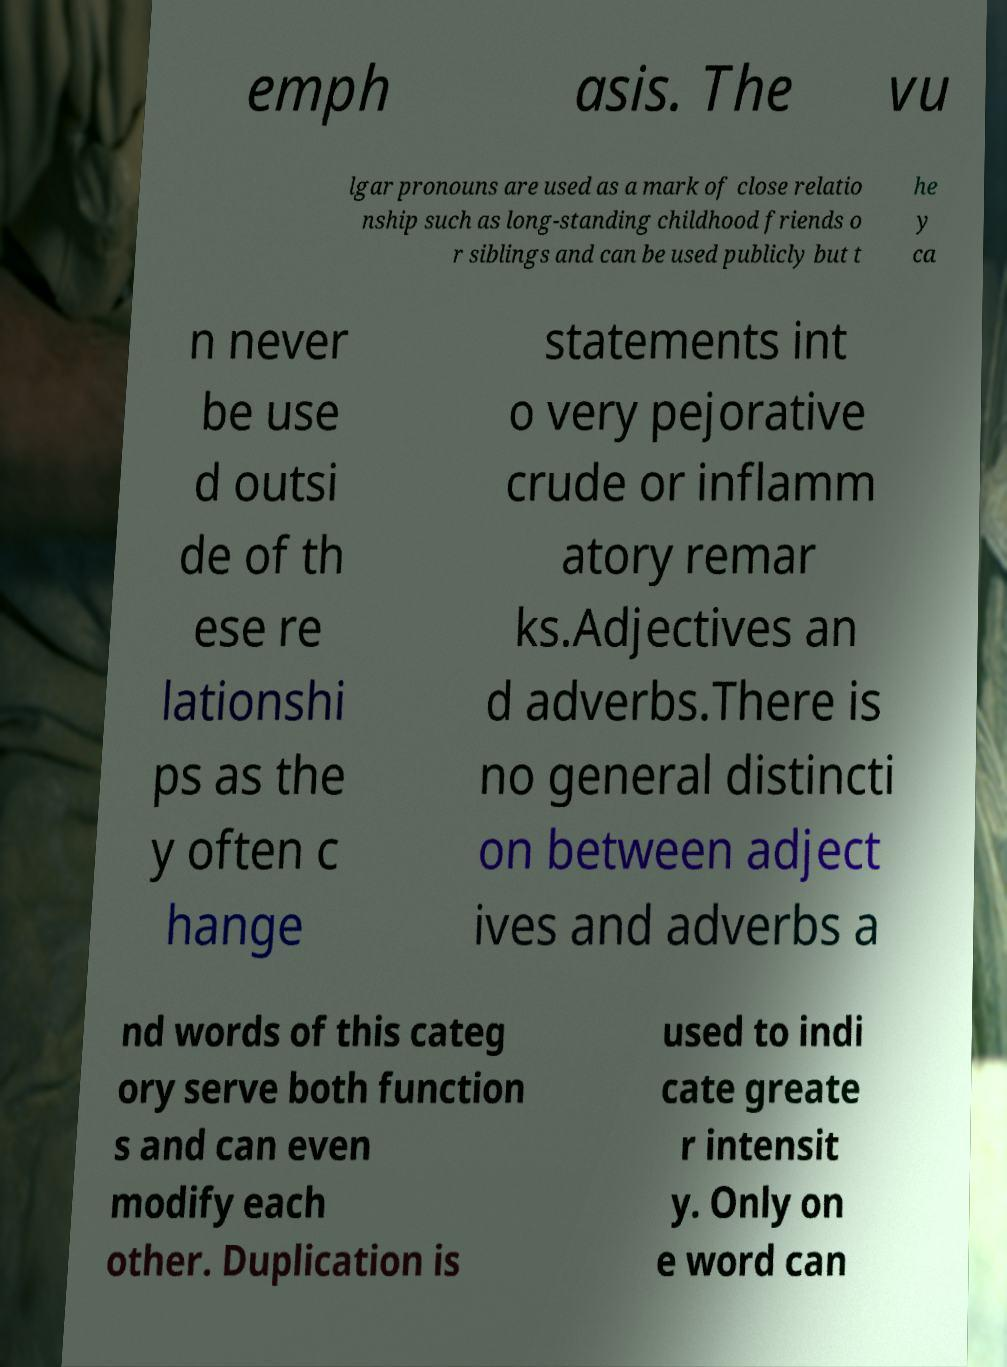For documentation purposes, I need the text within this image transcribed. Could you provide that? emph asis. The vu lgar pronouns are used as a mark of close relatio nship such as long-standing childhood friends o r siblings and can be used publicly but t he y ca n never be use d outsi de of th ese re lationshi ps as the y often c hange statements int o very pejorative crude or inflamm atory remar ks.Adjectives an d adverbs.There is no general distincti on between adject ives and adverbs a nd words of this categ ory serve both function s and can even modify each other. Duplication is used to indi cate greate r intensit y. Only on e word can 